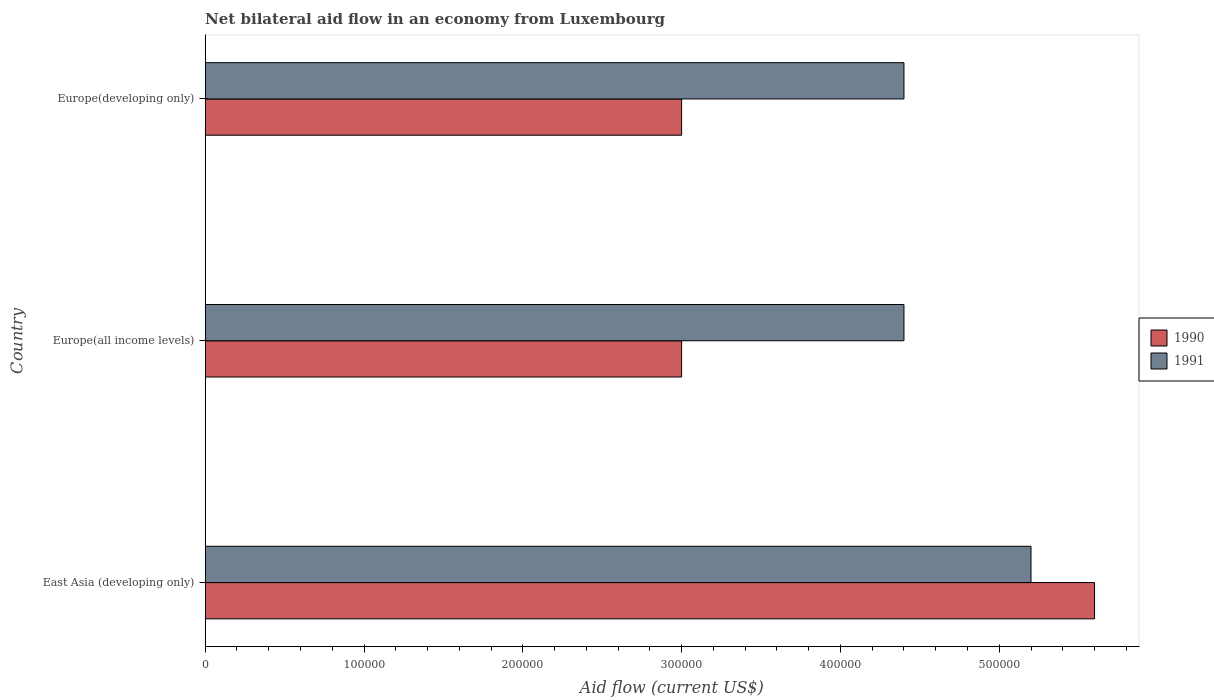How many different coloured bars are there?
Your answer should be compact. 2. How many groups of bars are there?
Your response must be concise. 3. How many bars are there on the 3rd tick from the top?
Offer a very short reply. 2. What is the label of the 3rd group of bars from the top?
Give a very brief answer. East Asia (developing only). Across all countries, what is the maximum net bilateral aid flow in 1990?
Make the answer very short. 5.60e+05. Across all countries, what is the minimum net bilateral aid flow in 1991?
Offer a terse response. 4.40e+05. In which country was the net bilateral aid flow in 1990 maximum?
Provide a short and direct response. East Asia (developing only). In which country was the net bilateral aid flow in 1990 minimum?
Offer a terse response. Europe(all income levels). What is the total net bilateral aid flow in 1990 in the graph?
Your response must be concise. 1.16e+06. What is the difference between the net bilateral aid flow in 1990 in East Asia (developing only) and the net bilateral aid flow in 1991 in Europe(all income levels)?
Make the answer very short. 1.20e+05. What is the average net bilateral aid flow in 1990 per country?
Give a very brief answer. 3.87e+05. What is the difference between the net bilateral aid flow in 1991 and net bilateral aid flow in 1990 in East Asia (developing only)?
Your answer should be very brief. -4.00e+04. What is the ratio of the net bilateral aid flow in 1990 in East Asia (developing only) to that in Europe(developing only)?
Your answer should be very brief. 1.87. Is the net bilateral aid flow in 1991 in East Asia (developing only) less than that in Europe(all income levels)?
Your answer should be very brief. No. Is the difference between the net bilateral aid flow in 1991 in East Asia (developing only) and Europe(developing only) greater than the difference between the net bilateral aid flow in 1990 in East Asia (developing only) and Europe(developing only)?
Give a very brief answer. No. What is the difference between the highest and the second highest net bilateral aid flow in 1990?
Your answer should be very brief. 2.60e+05. What is the difference between the highest and the lowest net bilateral aid flow in 1990?
Give a very brief answer. 2.60e+05. What does the 1st bar from the bottom in Europe(all income levels) represents?
Your response must be concise. 1990. How many bars are there?
Offer a very short reply. 6. How many countries are there in the graph?
Offer a terse response. 3. Are the values on the major ticks of X-axis written in scientific E-notation?
Offer a terse response. No. Does the graph contain grids?
Keep it short and to the point. No. How many legend labels are there?
Offer a terse response. 2. How are the legend labels stacked?
Your answer should be very brief. Vertical. What is the title of the graph?
Your response must be concise. Net bilateral aid flow in an economy from Luxembourg. What is the label or title of the X-axis?
Ensure brevity in your answer.  Aid flow (current US$). What is the Aid flow (current US$) of 1990 in East Asia (developing only)?
Offer a very short reply. 5.60e+05. What is the Aid flow (current US$) of 1991 in East Asia (developing only)?
Your response must be concise. 5.20e+05. What is the Aid flow (current US$) of 1990 in Europe(all income levels)?
Ensure brevity in your answer.  3.00e+05. What is the Aid flow (current US$) of 1991 in Europe(all income levels)?
Ensure brevity in your answer.  4.40e+05. Across all countries, what is the maximum Aid flow (current US$) in 1990?
Your answer should be very brief. 5.60e+05. Across all countries, what is the maximum Aid flow (current US$) of 1991?
Give a very brief answer. 5.20e+05. Across all countries, what is the minimum Aid flow (current US$) of 1990?
Make the answer very short. 3.00e+05. Across all countries, what is the minimum Aid flow (current US$) in 1991?
Your response must be concise. 4.40e+05. What is the total Aid flow (current US$) of 1990 in the graph?
Your answer should be compact. 1.16e+06. What is the total Aid flow (current US$) in 1991 in the graph?
Offer a terse response. 1.40e+06. What is the difference between the Aid flow (current US$) of 1990 in East Asia (developing only) and that in Europe(developing only)?
Give a very brief answer. 2.60e+05. What is the difference between the Aid flow (current US$) of 1991 in Europe(all income levels) and that in Europe(developing only)?
Give a very brief answer. 0. What is the difference between the Aid flow (current US$) in 1990 in East Asia (developing only) and the Aid flow (current US$) in 1991 in Europe(all income levels)?
Make the answer very short. 1.20e+05. What is the difference between the Aid flow (current US$) of 1990 in East Asia (developing only) and the Aid flow (current US$) of 1991 in Europe(developing only)?
Your answer should be very brief. 1.20e+05. What is the average Aid flow (current US$) of 1990 per country?
Offer a terse response. 3.87e+05. What is the average Aid flow (current US$) in 1991 per country?
Your answer should be compact. 4.67e+05. What is the difference between the Aid flow (current US$) in 1990 and Aid flow (current US$) in 1991 in Europe(all income levels)?
Keep it short and to the point. -1.40e+05. What is the ratio of the Aid flow (current US$) in 1990 in East Asia (developing only) to that in Europe(all income levels)?
Provide a succinct answer. 1.87. What is the ratio of the Aid flow (current US$) of 1991 in East Asia (developing only) to that in Europe(all income levels)?
Give a very brief answer. 1.18. What is the ratio of the Aid flow (current US$) of 1990 in East Asia (developing only) to that in Europe(developing only)?
Provide a succinct answer. 1.87. What is the ratio of the Aid flow (current US$) of 1991 in East Asia (developing only) to that in Europe(developing only)?
Your response must be concise. 1.18. What is the ratio of the Aid flow (current US$) in 1990 in Europe(all income levels) to that in Europe(developing only)?
Ensure brevity in your answer.  1. What is the difference between the highest and the second highest Aid flow (current US$) of 1990?
Your response must be concise. 2.60e+05. What is the difference between the highest and the lowest Aid flow (current US$) of 1990?
Ensure brevity in your answer.  2.60e+05. 